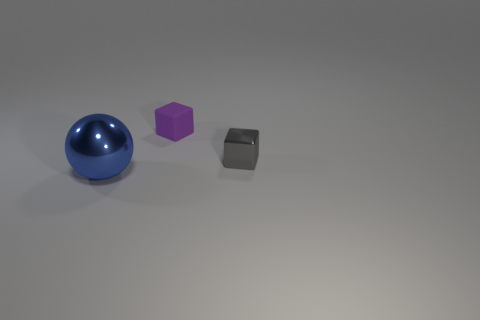There is a blue shiny sphere that is in front of the tiny thing behind the metal object that is behind the large thing; what is its size?
Make the answer very short. Large. There is a small thing on the right side of the tiny purple rubber object; is there a tiny matte thing that is left of it?
Offer a very short reply. Yes. There is a blue metallic thing; is it the same shape as the thing behind the gray thing?
Your answer should be compact. No. There is a metallic object that is on the left side of the purple matte object; what color is it?
Give a very brief answer. Blue. There is a shiny object in front of the metallic thing that is behind the big blue ball; what is its size?
Give a very brief answer. Large. There is a metal thing right of the rubber thing; does it have the same shape as the purple matte thing?
Give a very brief answer. Yes. There is a small purple object that is the same shape as the small gray object; what is it made of?
Keep it short and to the point. Rubber. What number of objects are either small blocks that are on the right side of the purple object or objects that are behind the large blue shiny object?
Provide a succinct answer. 2. Do the large ball and the metal object to the right of the large ball have the same color?
Ensure brevity in your answer.  No. There is a big blue thing that is the same material as the gray thing; what is its shape?
Keep it short and to the point. Sphere. 